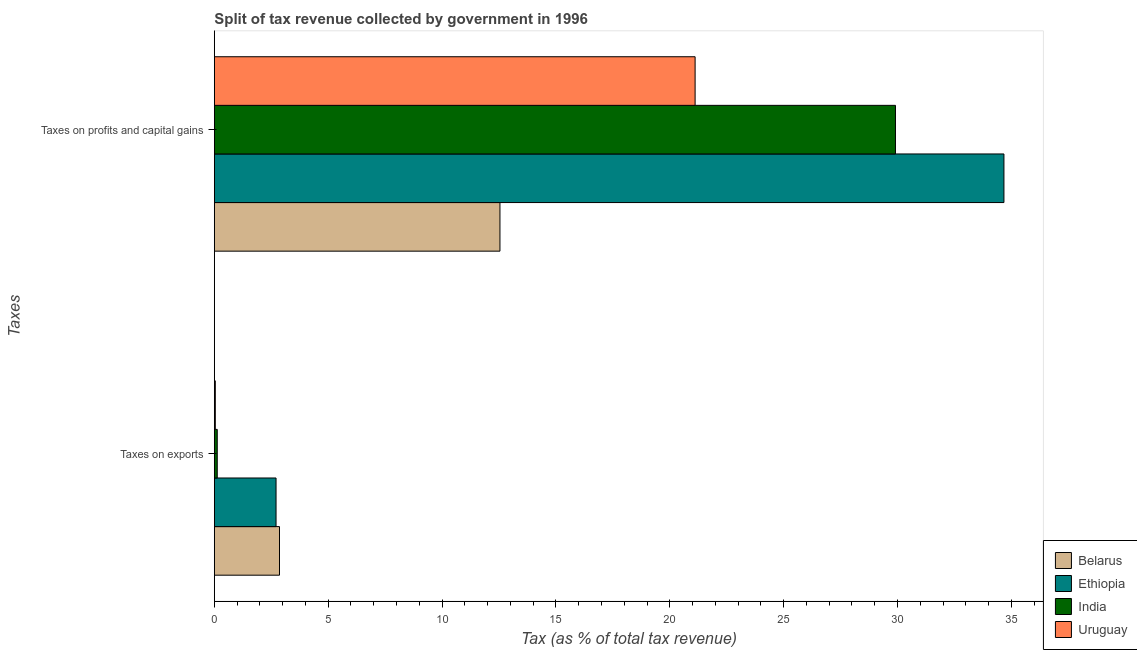Are the number of bars per tick equal to the number of legend labels?
Your response must be concise. Yes. What is the label of the 2nd group of bars from the top?
Provide a short and direct response. Taxes on exports. What is the percentage of revenue obtained from taxes on profits and capital gains in Belarus?
Ensure brevity in your answer.  12.54. Across all countries, what is the maximum percentage of revenue obtained from taxes on profits and capital gains?
Your answer should be very brief. 34.67. Across all countries, what is the minimum percentage of revenue obtained from taxes on exports?
Your answer should be compact. 0.04. In which country was the percentage of revenue obtained from taxes on profits and capital gains maximum?
Keep it short and to the point. Ethiopia. In which country was the percentage of revenue obtained from taxes on exports minimum?
Your response must be concise. Uruguay. What is the total percentage of revenue obtained from taxes on exports in the graph?
Keep it short and to the point. 5.74. What is the difference between the percentage of revenue obtained from taxes on exports in India and that in Belarus?
Give a very brief answer. -2.73. What is the difference between the percentage of revenue obtained from taxes on exports in Ethiopia and the percentage of revenue obtained from taxes on profits and capital gains in India?
Offer a very short reply. -27.2. What is the average percentage of revenue obtained from taxes on exports per country?
Give a very brief answer. 1.43. What is the difference between the percentage of revenue obtained from taxes on profits and capital gains and percentage of revenue obtained from taxes on exports in India?
Your answer should be very brief. 29.78. In how many countries, is the percentage of revenue obtained from taxes on exports greater than 15 %?
Your answer should be very brief. 0. What is the ratio of the percentage of revenue obtained from taxes on profits and capital gains in Belarus to that in Ethiopia?
Ensure brevity in your answer.  0.36. In how many countries, is the percentage of revenue obtained from taxes on exports greater than the average percentage of revenue obtained from taxes on exports taken over all countries?
Your answer should be compact. 2. What does the 4th bar from the bottom in Taxes on exports represents?
Keep it short and to the point. Uruguay. How many bars are there?
Ensure brevity in your answer.  8. Are all the bars in the graph horizontal?
Your answer should be compact. Yes. How many countries are there in the graph?
Keep it short and to the point. 4. Does the graph contain grids?
Your answer should be compact. No. How are the legend labels stacked?
Offer a terse response. Vertical. What is the title of the graph?
Keep it short and to the point. Split of tax revenue collected by government in 1996. What is the label or title of the X-axis?
Keep it short and to the point. Tax (as % of total tax revenue). What is the label or title of the Y-axis?
Your answer should be compact. Taxes. What is the Tax (as % of total tax revenue) in Belarus in Taxes on exports?
Ensure brevity in your answer.  2.86. What is the Tax (as % of total tax revenue) of Ethiopia in Taxes on exports?
Offer a very short reply. 2.71. What is the Tax (as % of total tax revenue) of India in Taxes on exports?
Keep it short and to the point. 0.13. What is the Tax (as % of total tax revenue) of Uruguay in Taxes on exports?
Provide a succinct answer. 0.04. What is the Tax (as % of total tax revenue) of Belarus in Taxes on profits and capital gains?
Ensure brevity in your answer.  12.54. What is the Tax (as % of total tax revenue) of Ethiopia in Taxes on profits and capital gains?
Keep it short and to the point. 34.67. What is the Tax (as % of total tax revenue) of India in Taxes on profits and capital gains?
Offer a terse response. 29.91. What is the Tax (as % of total tax revenue) in Uruguay in Taxes on profits and capital gains?
Make the answer very short. 21.11. Across all Taxes, what is the maximum Tax (as % of total tax revenue) in Belarus?
Ensure brevity in your answer.  12.54. Across all Taxes, what is the maximum Tax (as % of total tax revenue) in Ethiopia?
Your answer should be compact. 34.67. Across all Taxes, what is the maximum Tax (as % of total tax revenue) in India?
Offer a terse response. 29.91. Across all Taxes, what is the maximum Tax (as % of total tax revenue) of Uruguay?
Your answer should be compact. 21.11. Across all Taxes, what is the minimum Tax (as % of total tax revenue) of Belarus?
Provide a succinct answer. 2.86. Across all Taxes, what is the minimum Tax (as % of total tax revenue) in Ethiopia?
Offer a very short reply. 2.71. Across all Taxes, what is the minimum Tax (as % of total tax revenue) in India?
Provide a succinct answer. 0.13. Across all Taxes, what is the minimum Tax (as % of total tax revenue) of Uruguay?
Provide a succinct answer. 0.04. What is the total Tax (as % of total tax revenue) in Belarus in the graph?
Offer a terse response. 15.4. What is the total Tax (as % of total tax revenue) of Ethiopia in the graph?
Offer a terse response. 37.38. What is the total Tax (as % of total tax revenue) in India in the graph?
Provide a succinct answer. 30.04. What is the total Tax (as % of total tax revenue) in Uruguay in the graph?
Keep it short and to the point. 21.15. What is the difference between the Tax (as % of total tax revenue) of Belarus in Taxes on exports and that in Taxes on profits and capital gains?
Make the answer very short. -9.68. What is the difference between the Tax (as % of total tax revenue) in Ethiopia in Taxes on exports and that in Taxes on profits and capital gains?
Your answer should be compact. -31.96. What is the difference between the Tax (as % of total tax revenue) of India in Taxes on exports and that in Taxes on profits and capital gains?
Your response must be concise. -29.78. What is the difference between the Tax (as % of total tax revenue) in Uruguay in Taxes on exports and that in Taxes on profits and capital gains?
Give a very brief answer. -21.07. What is the difference between the Tax (as % of total tax revenue) in Belarus in Taxes on exports and the Tax (as % of total tax revenue) in Ethiopia in Taxes on profits and capital gains?
Offer a very short reply. -31.81. What is the difference between the Tax (as % of total tax revenue) of Belarus in Taxes on exports and the Tax (as % of total tax revenue) of India in Taxes on profits and capital gains?
Provide a short and direct response. -27.05. What is the difference between the Tax (as % of total tax revenue) in Belarus in Taxes on exports and the Tax (as % of total tax revenue) in Uruguay in Taxes on profits and capital gains?
Provide a short and direct response. -18.25. What is the difference between the Tax (as % of total tax revenue) in Ethiopia in Taxes on exports and the Tax (as % of total tax revenue) in India in Taxes on profits and capital gains?
Your answer should be very brief. -27.2. What is the difference between the Tax (as % of total tax revenue) in Ethiopia in Taxes on exports and the Tax (as % of total tax revenue) in Uruguay in Taxes on profits and capital gains?
Your answer should be compact. -18.4. What is the difference between the Tax (as % of total tax revenue) of India in Taxes on exports and the Tax (as % of total tax revenue) of Uruguay in Taxes on profits and capital gains?
Your response must be concise. -20.98. What is the average Tax (as % of total tax revenue) of Belarus per Taxes?
Your answer should be very brief. 7.7. What is the average Tax (as % of total tax revenue) of Ethiopia per Taxes?
Give a very brief answer. 18.69. What is the average Tax (as % of total tax revenue) of India per Taxes?
Offer a very short reply. 15.02. What is the average Tax (as % of total tax revenue) of Uruguay per Taxes?
Your answer should be very brief. 10.58. What is the difference between the Tax (as % of total tax revenue) in Belarus and Tax (as % of total tax revenue) in Ethiopia in Taxes on exports?
Offer a very short reply. 0.15. What is the difference between the Tax (as % of total tax revenue) in Belarus and Tax (as % of total tax revenue) in India in Taxes on exports?
Offer a very short reply. 2.73. What is the difference between the Tax (as % of total tax revenue) in Belarus and Tax (as % of total tax revenue) in Uruguay in Taxes on exports?
Give a very brief answer. 2.82. What is the difference between the Tax (as % of total tax revenue) in Ethiopia and Tax (as % of total tax revenue) in India in Taxes on exports?
Provide a short and direct response. 2.58. What is the difference between the Tax (as % of total tax revenue) of Ethiopia and Tax (as % of total tax revenue) of Uruguay in Taxes on exports?
Provide a succinct answer. 2.67. What is the difference between the Tax (as % of total tax revenue) of India and Tax (as % of total tax revenue) of Uruguay in Taxes on exports?
Provide a succinct answer. 0.09. What is the difference between the Tax (as % of total tax revenue) of Belarus and Tax (as % of total tax revenue) of Ethiopia in Taxes on profits and capital gains?
Ensure brevity in your answer.  -22.13. What is the difference between the Tax (as % of total tax revenue) in Belarus and Tax (as % of total tax revenue) in India in Taxes on profits and capital gains?
Give a very brief answer. -17.37. What is the difference between the Tax (as % of total tax revenue) of Belarus and Tax (as % of total tax revenue) of Uruguay in Taxes on profits and capital gains?
Your response must be concise. -8.57. What is the difference between the Tax (as % of total tax revenue) of Ethiopia and Tax (as % of total tax revenue) of India in Taxes on profits and capital gains?
Your answer should be compact. 4.76. What is the difference between the Tax (as % of total tax revenue) of Ethiopia and Tax (as % of total tax revenue) of Uruguay in Taxes on profits and capital gains?
Make the answer very short. 13.56. What is the difference between the Tax (as % of total tax revenue) of India and Tax (as % of total tax revenue) of Uruguay in Taxes on profits and capital gains?
Your answer should be very brief. 8.8. What is the ratio of the Tax (as % of total tax revenue) of Belarus in Taxes on exports to that in Taxes on profits and capital gains?
Your answer should be compact. 0.23. What is the ratio of the Tax (as % of total tax revenue) of Ethiopia in Taxes on exports to that in Taxes on profits and capital gains?
Your answer should be very brief. 0.08. What is the ratio of the Tax (as % of total tax revenue) in India in Taxes on exports to that in Taxes on profits and capital gains?
Ensure brevity in your answer.  0. What is the ratio of the Tax (as % of total tax revenue) of Uruguay in Taxes on exports to that in Taxes on profits and capital gains?
Make the answer very short. 0. What is the difference between the highest and the second highest Tax (as % of total tax revenue) in Belarus?
Your response must be concise. 9.68. What is the difference between the highest and the second highest Tax (as % of total tax revenue) in Ethiopia?
Offer a very short reply. 31.96. What is the difference between the highest and the second highest Tax (as % of total tax revenue) of India?
Make the answer very short. 29.78. What is the difference between the highest and the second highest Tax (as % of total tax revenue) of Uruguay?
Offer a very short reply. 21.07. What is the difference between the highest and the lowest Tax (as % of total tax revenue) of Belarus?
Offer a very short reply. 9.68. What is the difference between the highest and the lowest Tax (as % of total tax revenue) in Ethiopia?
Provide a short and direct response. 31.96. What is the difference between the highest and the lowest Tax (as % of total tax revenue) in India?
Your response must be concise. 29.78. What is the difference between the highest and the lowest Tax (as % of total tax revenue) of Uruguay?
Make the answer very short. 21.07. 